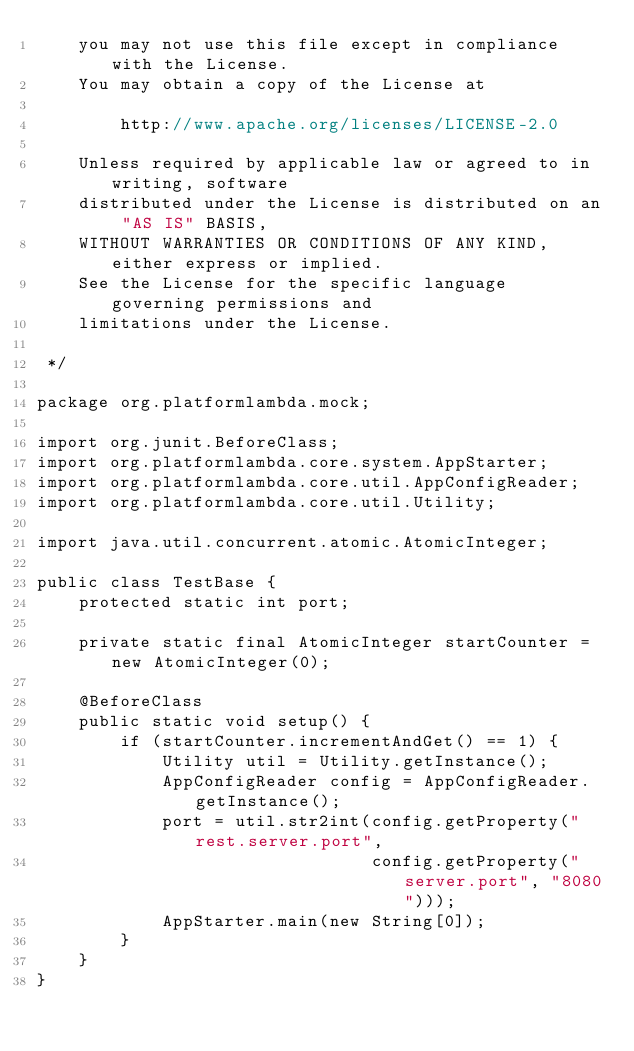Convert code to text. <code><loc_0><loc_0><loc_500><loc_500><_Java_>    you may not use this file except in compliance with the License.
    You may obtain a copy of the License at

        http://www.apache.org/licenses/LICENSE-2.0

    Unless required by applicable law or agreed to in writing, software
    distributed under the License is distributed on an "AS IS" BASIS,
    WITHOUT WARRANTIES OR CONDITIONS OF ANY KIND, either express or implied.
    See the License for the specific language governing permissions and
    limitations under the License.

 */

package org.platformlambda.mock;

import org.junit.BeforeClass;
import org.platformlambda.core.system.AppStarter;
import org.platformlambda.core.util.AppConfigReader;
import org.platformlambda.core.util.Utility;

import java.util.concurrent.atomic.AtomicInteger;

public class TestBase {
    protected static int port;

    private static final AtomicInteger startCounter = new AtomicInteger(0);

    @BeforeClass
    public static void setup() {
        if (startCounter.incrementAndGet() == 1) {
            Utility util = Utility.getInstance();
            AppConfigReader config = AppConfigReader.getInstance();
            port = util.str2int(config.getProperty("rest.server.port",
                                config.getProperty("server.port", "8080")));
            AppStarter.main(new String[0]);
        }
    }
}
</code> 